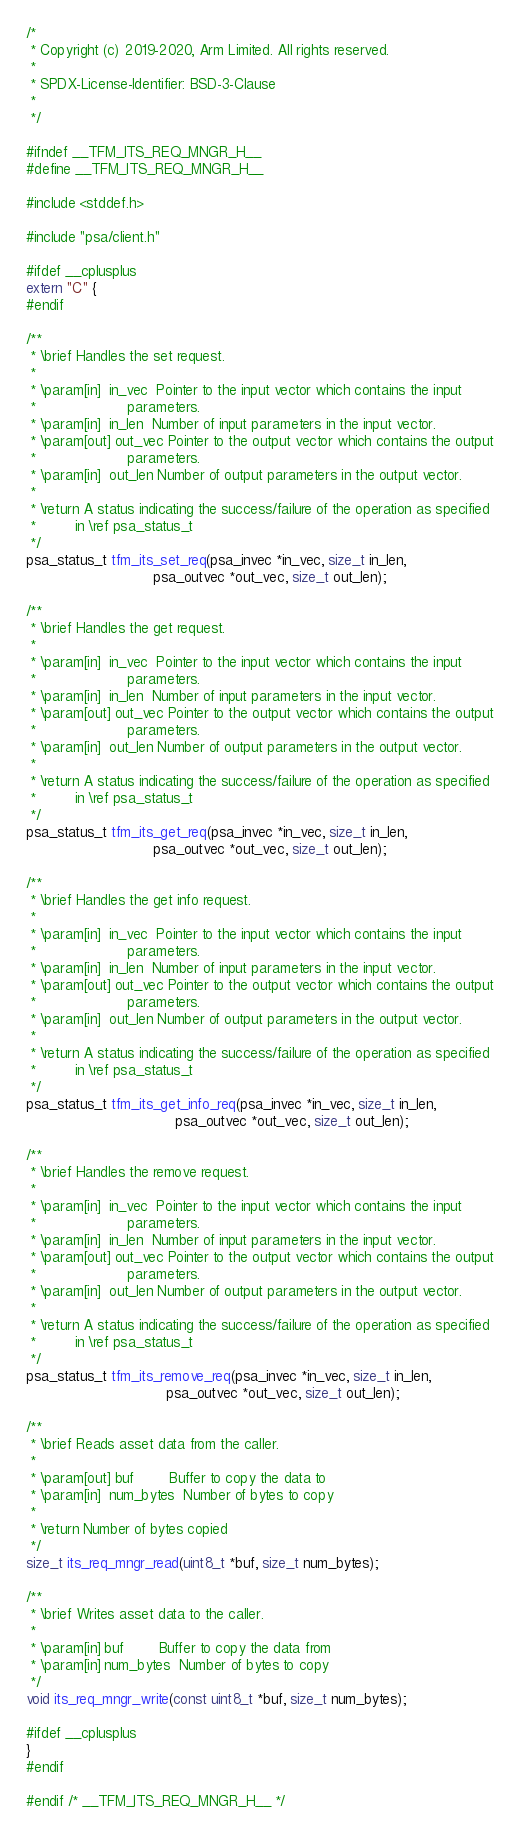Convert code to text. <code><loc_0><loc_0><loc_500><loc_500><_C_>/*
 * Copyright (c) 2019-2020, Arm Limited. All rights reserved.
 *
 * SPDX-License-Identifier: BSD-3-Clause
 *
 */

#ifndef __TFM_ITS_REQ_MNGR_H__
#define __TFM_ITS_REQ_MNGR_H__

#include <stddef.h>

#include "psa/client.h"

#ifdef __cplusplus
extern "C" {
#endif

/**
 * \brief Handles the set request.
 *
 * \param[in]  in_vec  Pointer to the input vector which contains the input
 *                     parameters.
 * \param[in]  in_len  Number of input parameters in the input vector.
 * \param[out] out_vec Pointer to the output vector which contains the output
 *                     parameters.
 * \param[in]  out_len Number of output parameters in the output vector.
 *
 * \return A status indicating the success/failure of the operation as specified
 *         in \ref psa_status_t
 */
psa_status_t tfm_its_set_req(psa_invec *in_vec, size_t in_len,
                             psa_outvec *out_vec, size_t out_len);

/**
 * \brief Handles the get request.
 *
 * \param[in]  in_vec  Pointer to the input vector which contains the input
 *                     parameters.
 * \param[in]  in_len  Number of input parameters in the input vector.
 * \param[out] out_vec Pointer to the output vector which contains the output
 *                     parameters.
 * \param[in]  out_len Number of output parameters in the output vector.
 *
 * \return A status indicating the success/failure of the operation as specified
 *         in \ref psa_status_t
 */
psa_status_t tfm_its_get_req(psa_invec *in_vec, size_t in_len,
                             psa_outvec *out_vec, size_t out_len);

/**
 * \brief Handles the get info request.
 *
 * \param[in]  in_vec  Pointer to the input vector which contains the input
 *                     parameters.
 * \param[in]  in_len  Number of input parameters in the input vector.
 * \param[out] out_vec Pointer to the output vector which contains the output
 *                     parameters.
 * \param[in]  out_len Number of output parameters in the output vector.
 *
 * \return A status indicating the success/failure of the operation as specified
 *         in \ref psa_status_t
 */
psa_status_t tfm_its_get_info_req(psa_invec *in_vec, size_t in_len,
                                  psa_outvec *out_vec, size_t out_len);

/**
 * \brief Handles the remove request.
 *
 * \param[in]  in_vec  Pointer to the input vector which contains the input
 *                     parameters.
 * \param[in]  in_len  Number of input parameters in the input vector.
 * \param[out] out_vec Pointer to the output vector which contains the output
 *                     parameters.
 * \param[in]  out_len Number of output parameters in the output vector.
 *
 * \return A status indicating the success/failure of the operation as specified
 *         in \ref psa_status_t
 */
psa_status_t tfm_its_remove_req(psa_invec *in_vec, size_t in_len,
                                psa_outvec *out_vec, size_t out_len);

/**
 * \brief Reads asset data from the caller.
 *
 * \param[out] buf        Buffer to copy the data to
 * \param[in]  num_bytes  Number of bytes to copy
 *
 * \return Number of bytes copied
 */
size_t its_req_mngr_read(uint8_t *buf, size_t num_bytes);

/**
 * \brief Writes asset data to the caller.
 *
 * \param[in] buf        Buffer to copy the data from
 * \param[in] num_bytes  Number of bytes to copy
 */
void its_req_mngr_write(const uint8_t *buf, size_t num_bytes);

#ifdef __cplusplus
}
#endif

#endif /* __TFM_ITS_REQ_MNGR_H__ */
</code> 